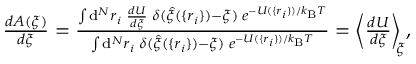Convert formula to latex. <formula><loc_0><loc_0><loc_500><loc_500>\begin{array} { r } { \frac { d A ( \xi ) } { d \xi } = \frac { \int d ^ { N } r _ { i } \, \frac { d U } { d \xi } \, \delta ( \hat { \xi } ( \{ r _ { i } \} ) - \xi ) \, e ^ { - U ( \{ r _ { i } \} ) / k _ { B } T } } { \int d ^ { N } r _ { i } \, \delta ( \hat { \xi } ( \{ r _ { i } \} ) - \xi ) \, e ^ { - U ( \{ r _ { i } \} ) / k _ { B } T } } = \left \langle \frac { d U } { d \xi } \right \rangle _ { \, \xi } , } \end{array}</formula> 